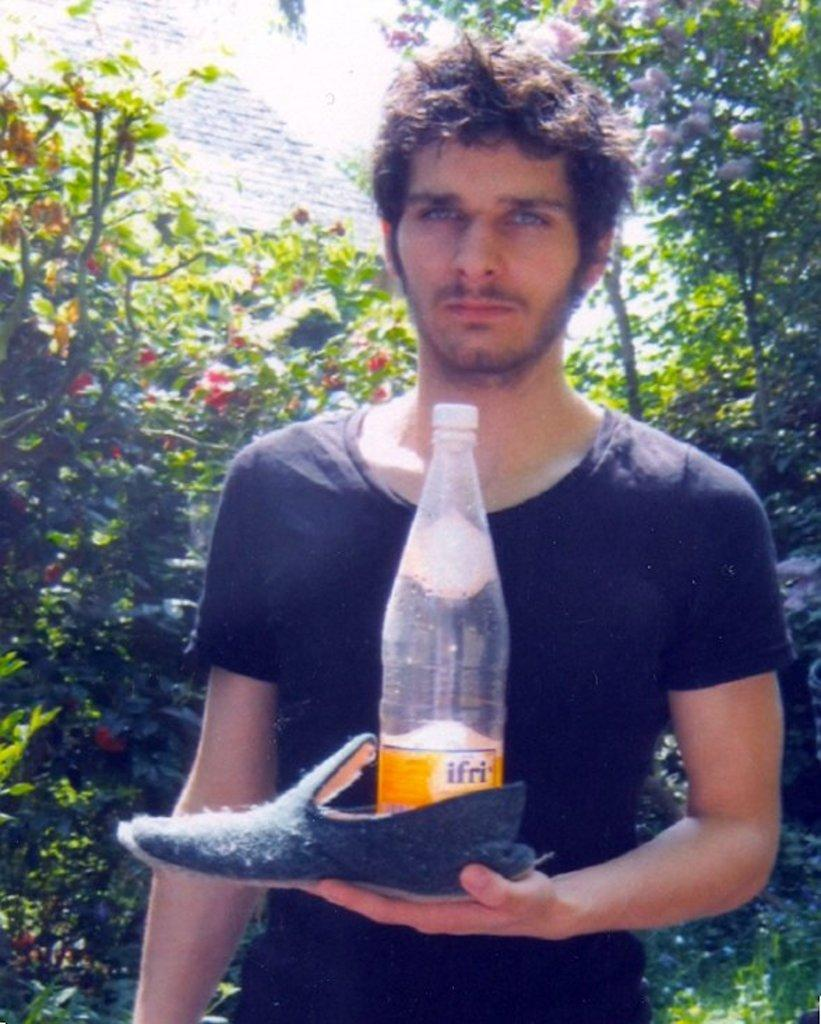What is the person in the image wearing? The person is wearing a black t-shirt. What is the person holding in their hand? The person is holding a shoe in their hand. What is inside the shoe? There is a bottle in the shoe. What can be seen in the background of the image? Trees are visible in the background of the image. What type of flame can be seen coming from the stove in the image? There is no stove or flame present in the image. 